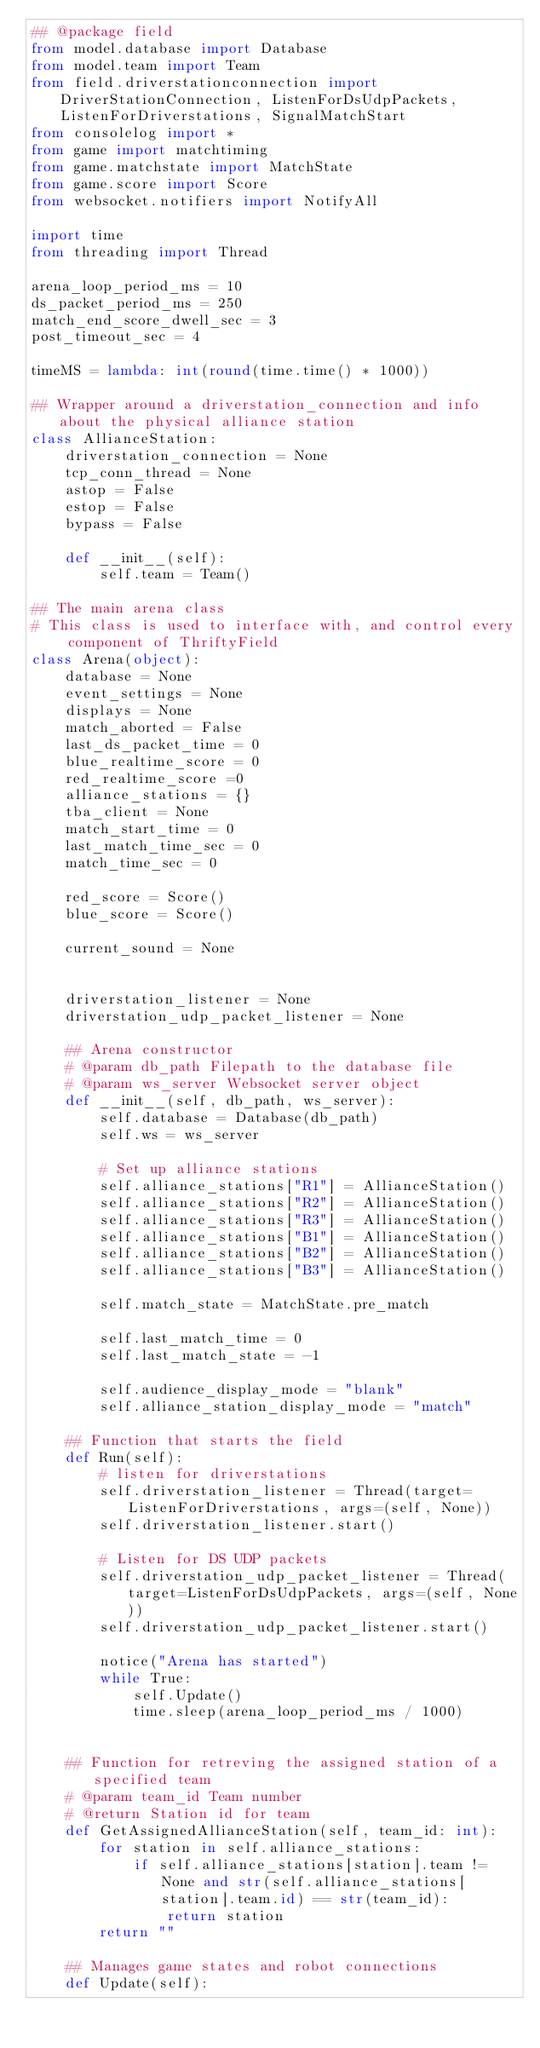<code> <loc_0><loc_0><loc_500><loc_500><_Python_>## @package field
from model.database import Database
from model.team import Team
from field.driverstationconnection import DriverStationConnection, ListenForDsUdpPackets, ListenForDriverstations, SignalMatchStart
from consolelog import *
from game import matchtiming
from game.matchstate import MatchState
from game.score import Score
from websocket.notifiers import NotifyAll

import time
from threading import Thread

arena_loop_period_ms = 10
ds_packet_period_ms = 250
match_end_score_dwell_sec = 3
post_timeout_sec = 4

timeMS = lambda: int(round(time.time() * 1000))

## Wrapper around a driverstation_connection and info about the physical alliance station
class AllianceStation:
    driverstation_connection = None
    tcp_conn_thread = None
    astop = False
    estop = False
    bypass = False

    def __init__(self):
        self.team = Team()

## The main arena class
# This class is used to interface with, and control every component of ThriftyField
class Arena(object):
    database = None
    event_settings = None
    displays = None
    match_aborted = False
    last_ds_packet_time = 0
    blue_realtime_score = 0
    red_realtime_score =0
    alliance_stations = {}
    tba_client = None
    match_start_time = 0
    last_match_time_sec = 0
    match_time_sec = 0

    red_score = Score()
    blue_score = Score()

    current_sound = None
    

    driverstation_listener = None
    driverstation_udp_packet_listener = None

    ## Arena constructor
    # @param db_path Filepath to the database file
    # @param ws_server Websocket server object
    def __init__(self, db_path, ws_server):
        self.database = Database(db_path)
        self.ws = ws_server

        # Set up alliance stations
        self.alliance_stations["R1"] = AllianceStation()
        self.alliance_stations["R2"] = AllianceStation()
        self.alliance_stations["R3"] = AllianceStation()
        self.alliance_stations["B1"] = AllianceStation()
        self.alliance_stations["B2"] = AllianceStation()
        self.alliance_stations["B3"] = AllianceStation()

        self.match_state = MatchState.pre_match

        self.last_match_time = 0
        self.last_match_state = -1

        self.audience_display_mode = "blank"
        self.alliance_station_display_mode = "match"
    
    ## Function that starts the field
    def Run(self):
        # listen for driverstations
        self.driverstation_listener = Thread(target=ListenForDriverstations, args=(self, None))
        self.driverstation_listener.start()

        # Listen for DS UDP packets
        self.driverstation_udp_packet_listener = Thread(target=ListenForDsUdpPackets, args=(self, None))
        self.driverstation_udp_packet_listener.start()

        notice("Arena has started")
        while True:
            self.Update()
            time.sleep(arena_loop_period_ms / 1000)
        

    ## Function for retreving the assigned station of a specified team
    # @param team_id Team number
    # @return Station id for team
    def GetAssignedAllianceStation(self, team_id: int):
        for station in self.alliance_stations:
            if self.alliance_stations[station].team != None and str(self.alliance_stations[station].team.id) == str(team_id):
                return station
        return ""

    ## Manages game states and robot connections
    def Update(self):</code> 